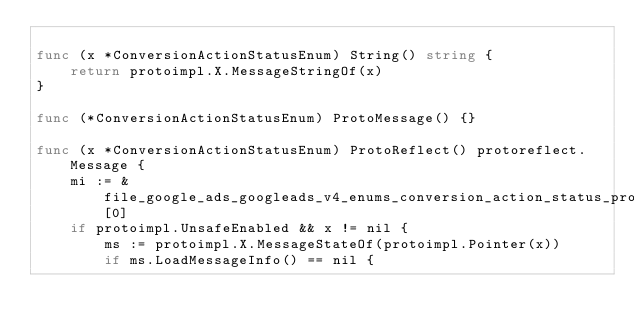<code> <loc_0><loc_0><loc_500><loc_500><_Go_>
func (x *ConversionActionStatusEnum) String() string {
	return protoimpl.X.MessageStringOf(x)
}

func (*ConversionActionStatusEnum) ProtoMessage() {}

func (x *ConversionActionStatusEnum) ProtoReflect() protoreflect.Message {
	mi := &file_google_ads_googleads_v4_enums_conversion_action_status_proto_msgTypes[0]
	if protoimpl.UnsafeEnabled && x != nil {
		ms := protoimpl.X.MessageStateOf(protoimpl.Pointer(x))
		if ms.LoadMessageInfo() == nil {</code> 